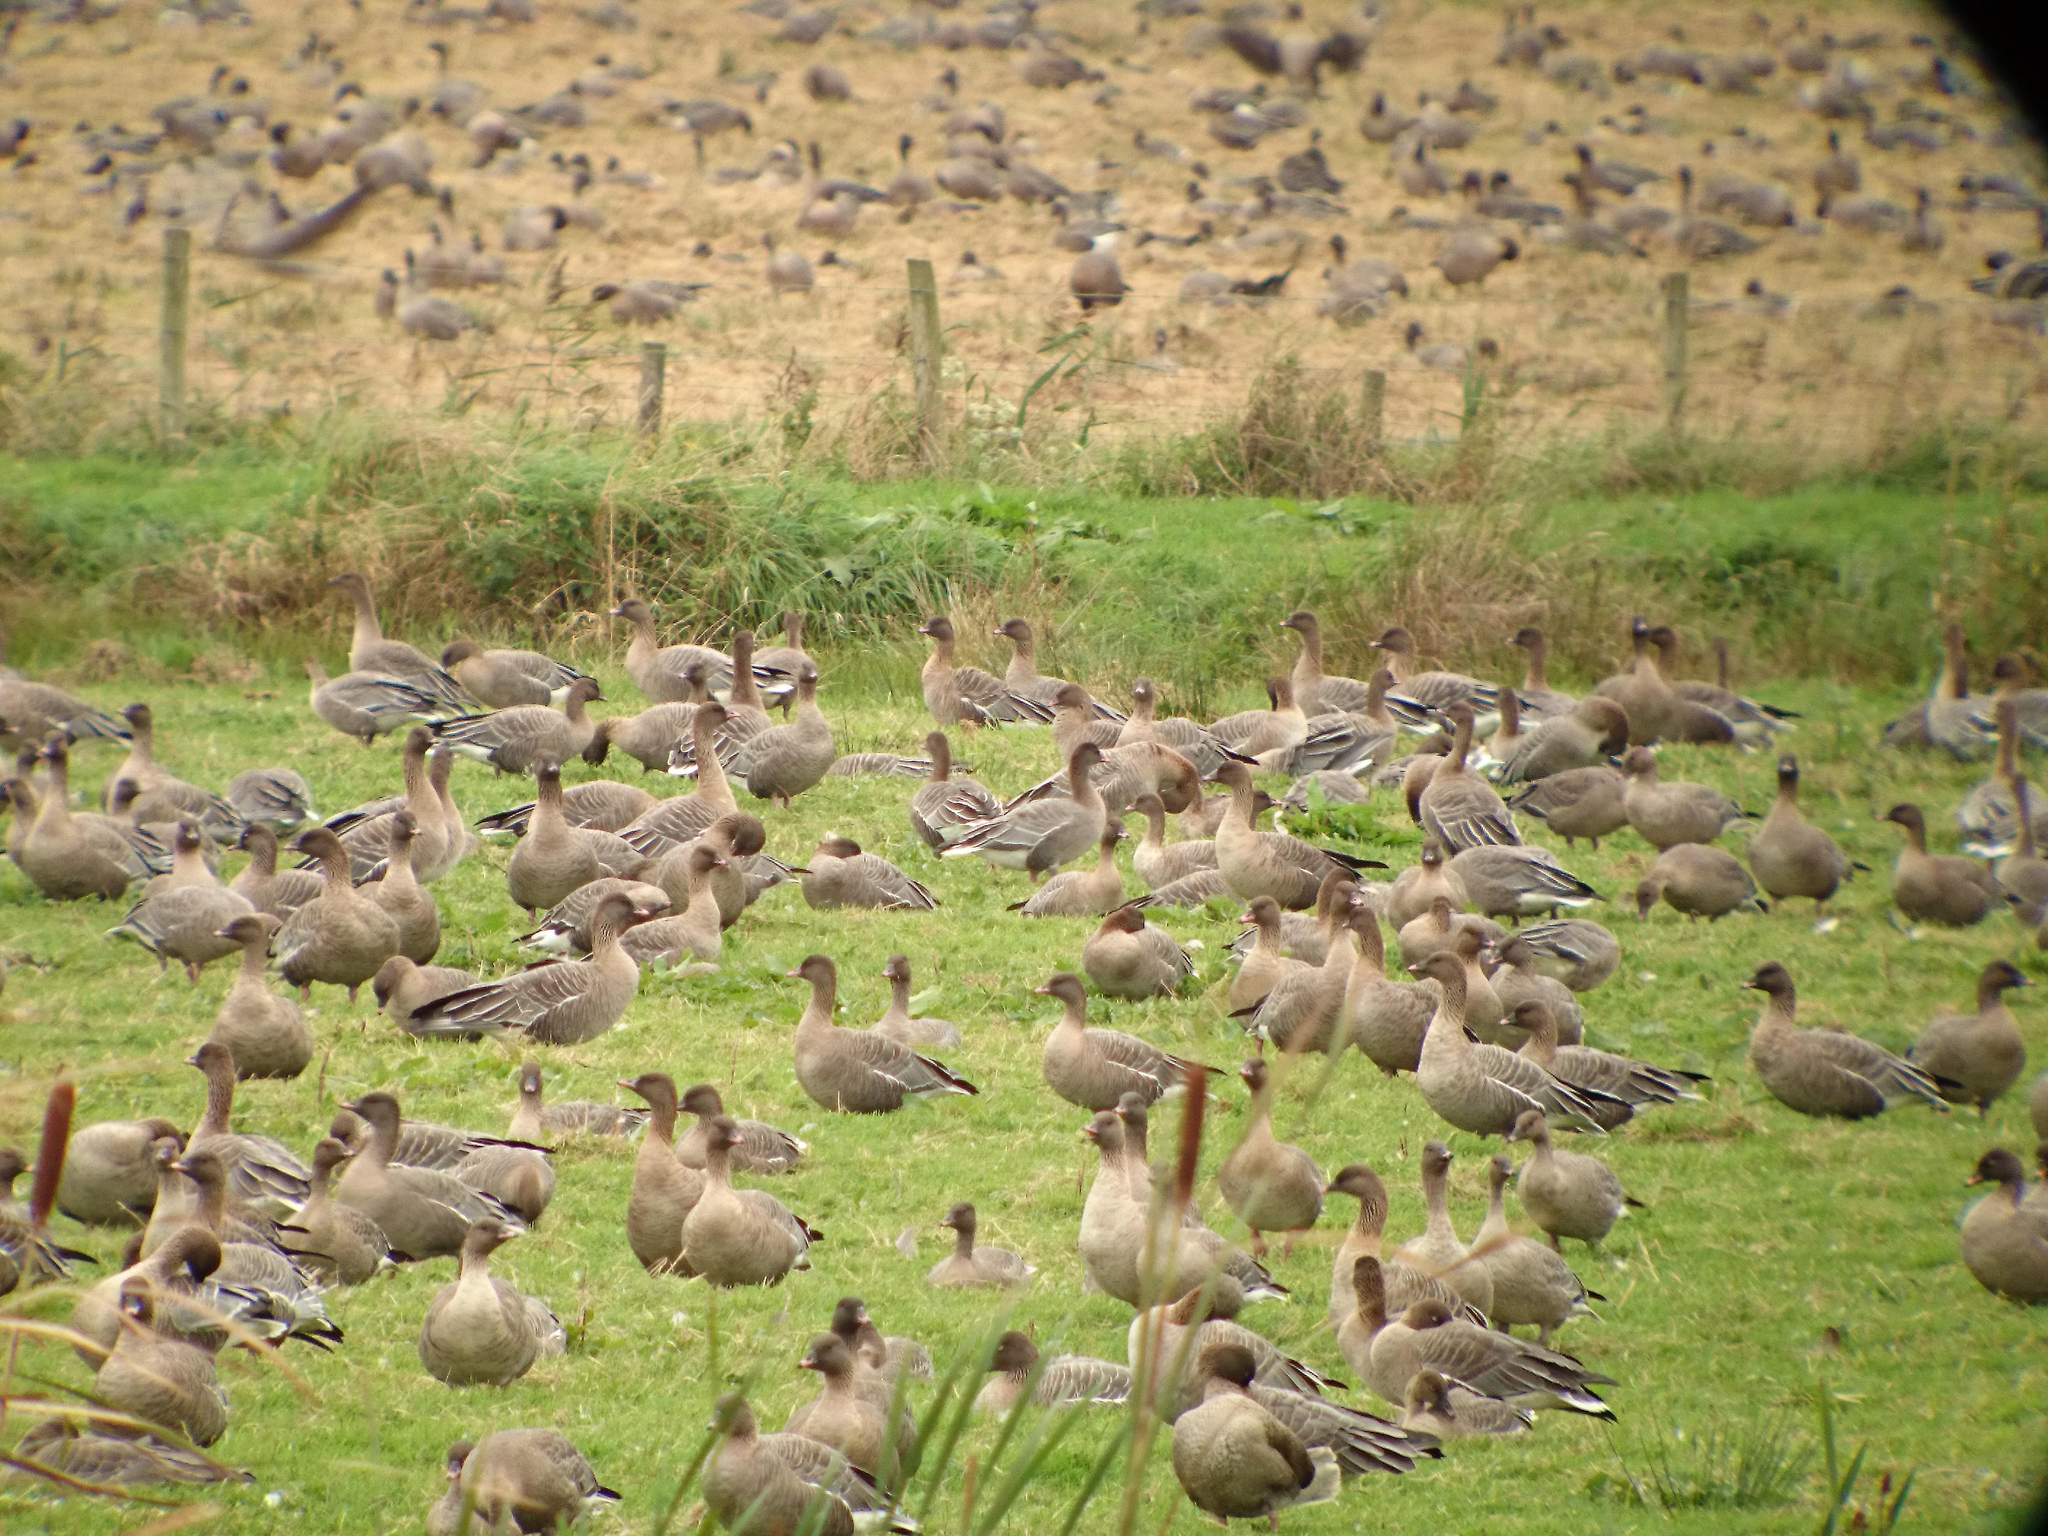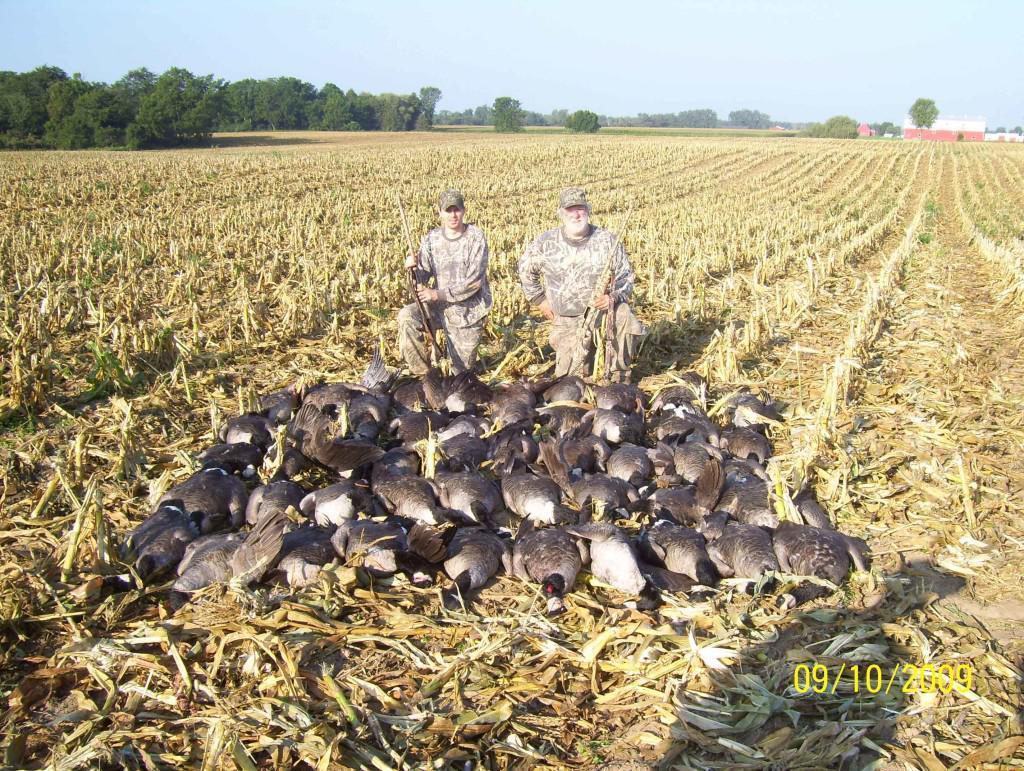The first image is the image on the left, the second image is the image on the right. For the images displayed, is the sentence "The birds in the image on the right are primarily white." factually correct? Answer yes or no. No. The first image is the image on the left, the second image is the image on the right. Given the left and right images, does the statement "Someone is in the field with the animals." hold true? Answer yes or no. Yes. 